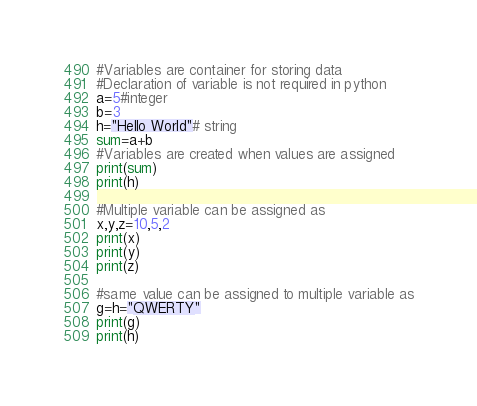Convert code to text. <code><loc_0><loc_0><loc_500><loc_500><_Python_>#Variables are container for storing data
#Declaration of variable is not required in python
a=5#integer
b=3
h="Hello World"# string
sum=a+b
#Variables are created when values are assigned
print(sum)
print(h)

#Multiple variable can be assigned as
x,y,z=10,5,2
print(x)
print(y)
print(z)

#same value can be assigned to multiple variable as
g=h="QWERTY"
print(g)
print(h)


</code> 